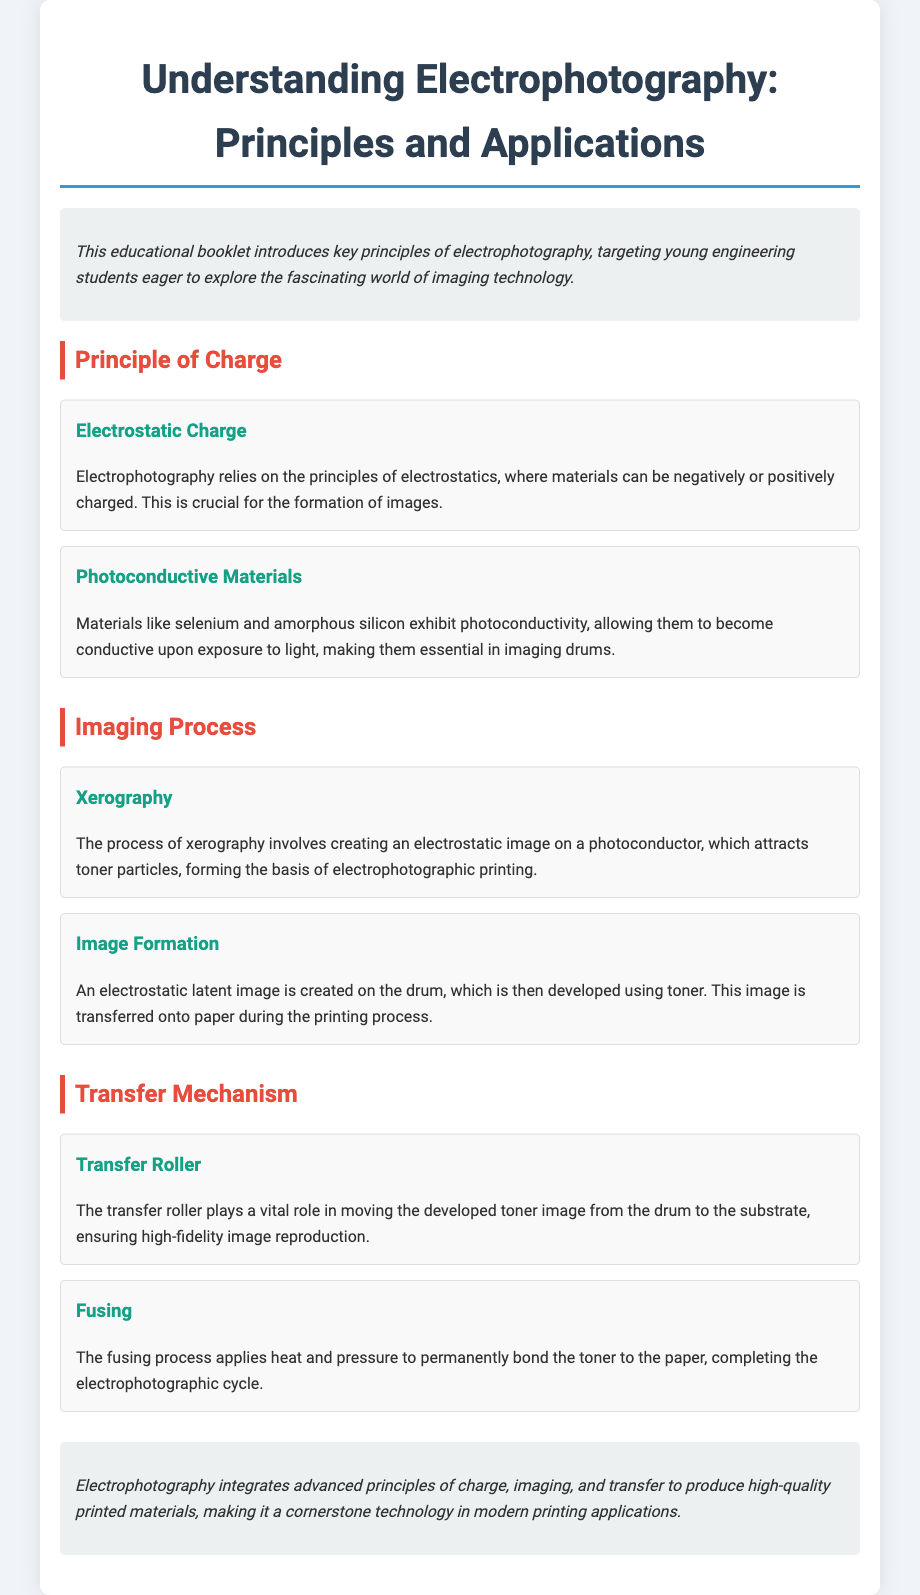What is the title of the booklet? The title is displayed prominently at the top of the document, summarizing its focus on electrophotography principles and applications.
Answer: Understanding Electrophotography: Principles and Applications What materials exhibit photoconductivity? The document specifies the materials that become conductive upon exposure to light, highlighting their role in electrophotography.
Answer: Selenium and amorphous silicon What is the process called that involves creating an electrostatic image? The document details this process in the imaging section, introducing its terminology relevant to electrophotography.
Answer: Xerography What is the role of the transfer roller? The document explains the function of this component in ensuring high-fidelity image reproduction during the transfer stage.
Answer: Moving developed toner image What completes the electrophotographic cycle? The conclusion summarizes the final step in the process, which is crucial for the permanency of printed materials.
Answer: Fusing What creates the electrostatic latent image? This question requires understanding of the imaging section's explanation of how images are formed in electrophotography.
Answer: On the drum 